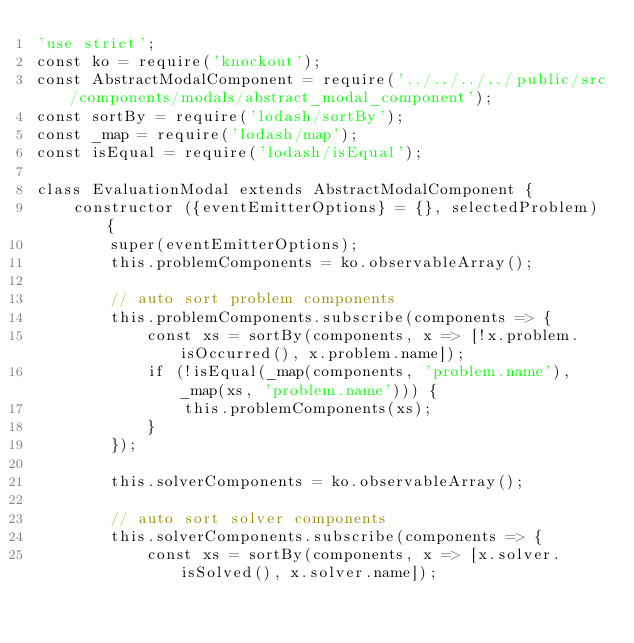Convert code to text. <code><loc_0><loc_0><loc_500><loc_500><_JavaScript_>'use strict';
const ko = require('knockout');
const AbstractModalComponent = require('../../../../public/src/components/modals/abstract_modal_component');
const sortBy = require('lodash/sortBy');
const _map = require('lodash/map');
const isEqual = require('lodash/isEqual');

class EvaluationModal extends AbstractModalComponent {
    constructor ({eventEmitterOptions} = {}, selectedProblem) {
        super(eventEmitterOptions);
        this.problemComponents = ko.observableArray();

        // auto sort problem components
        this.problemComponents.subscribe(components => {
            const xs = sortBy(components, x => [!x.problem.isOccurred(), x.problem.name]);
            if (!isEqual(_map(components, 'problem.name'), _map(xs, 'problem.name'))) {
                this.problemComponents(xs);
            }
        });

        this.solverComponents = ko.observableArray();

        // auto sort solver components
        this.solverComponents.subscribe(components => {
            const xs = sortBy(components, x => [x.solver.isSolved(), x.solver.name]);</code> 